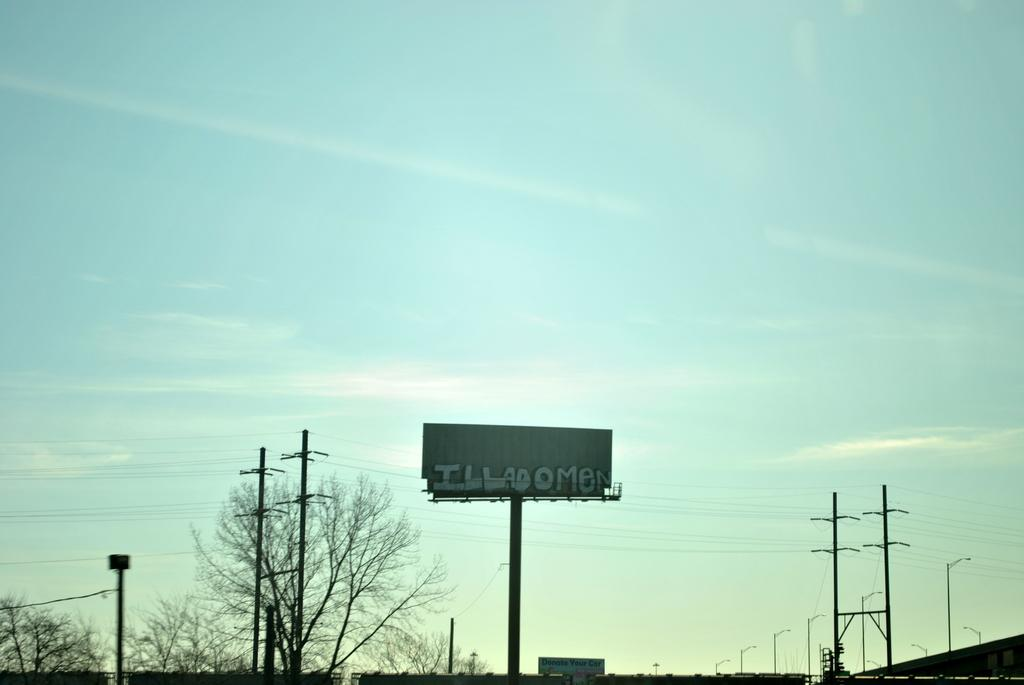<image>
Give a short and clear explanation of the subsequent image. A billboard sign with the word ILLADOMEN on it 